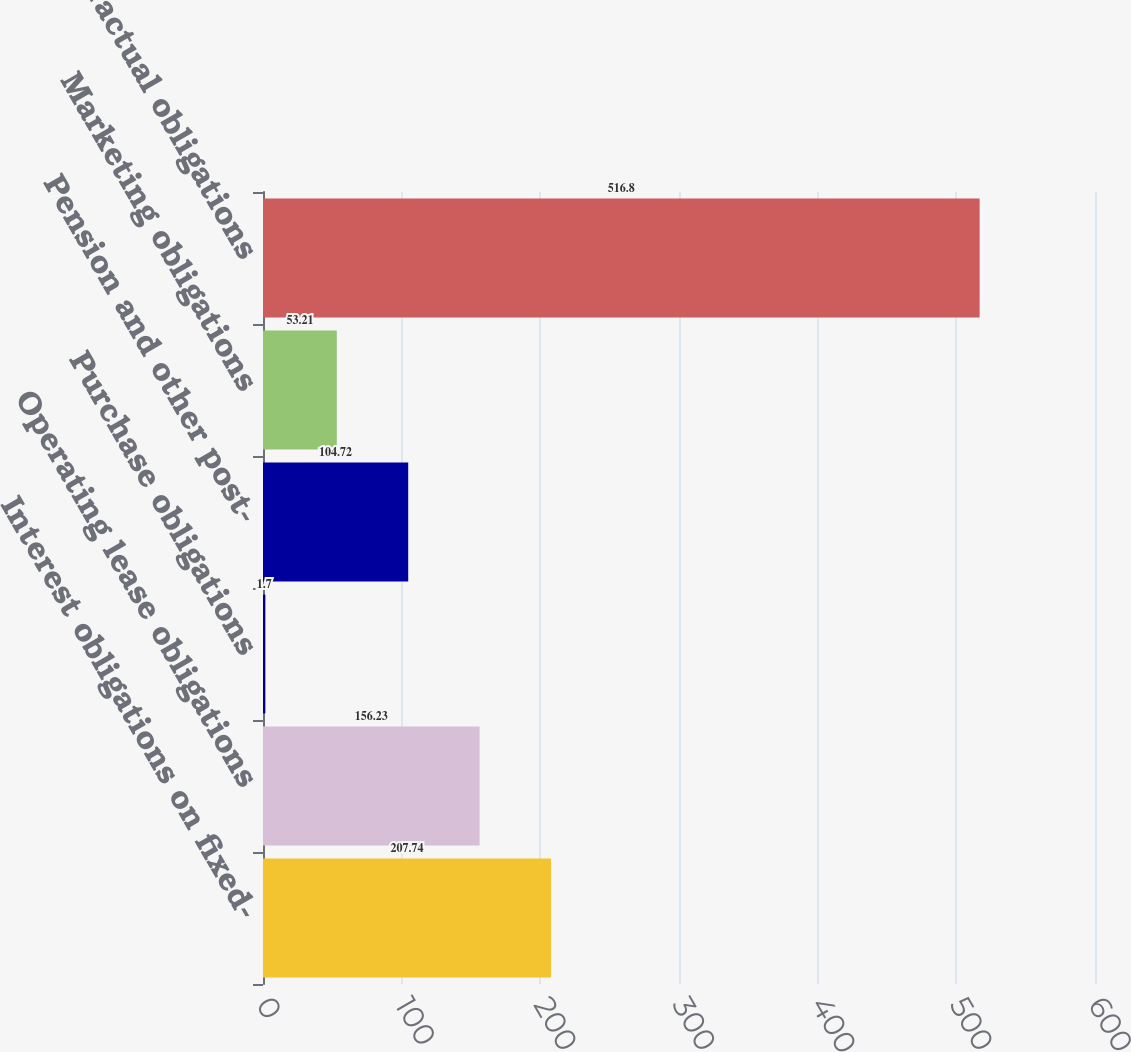Convert chart. <chart><loc_0><loc_0><loc_500><loc_500><bar_chart><fcel>Interest obligations on fixed-<fcel>Operating lease obligations<fcel>Purchase obligations<fcel>Pension and other post-<fcel>Marketing obligations<fcel>Total contractual obligations<nl><fcel>207.74<fcel>156.23<fcel>1.7<fcel>104.72<fcel>53.21<fcel>516.8<nl></chart> 